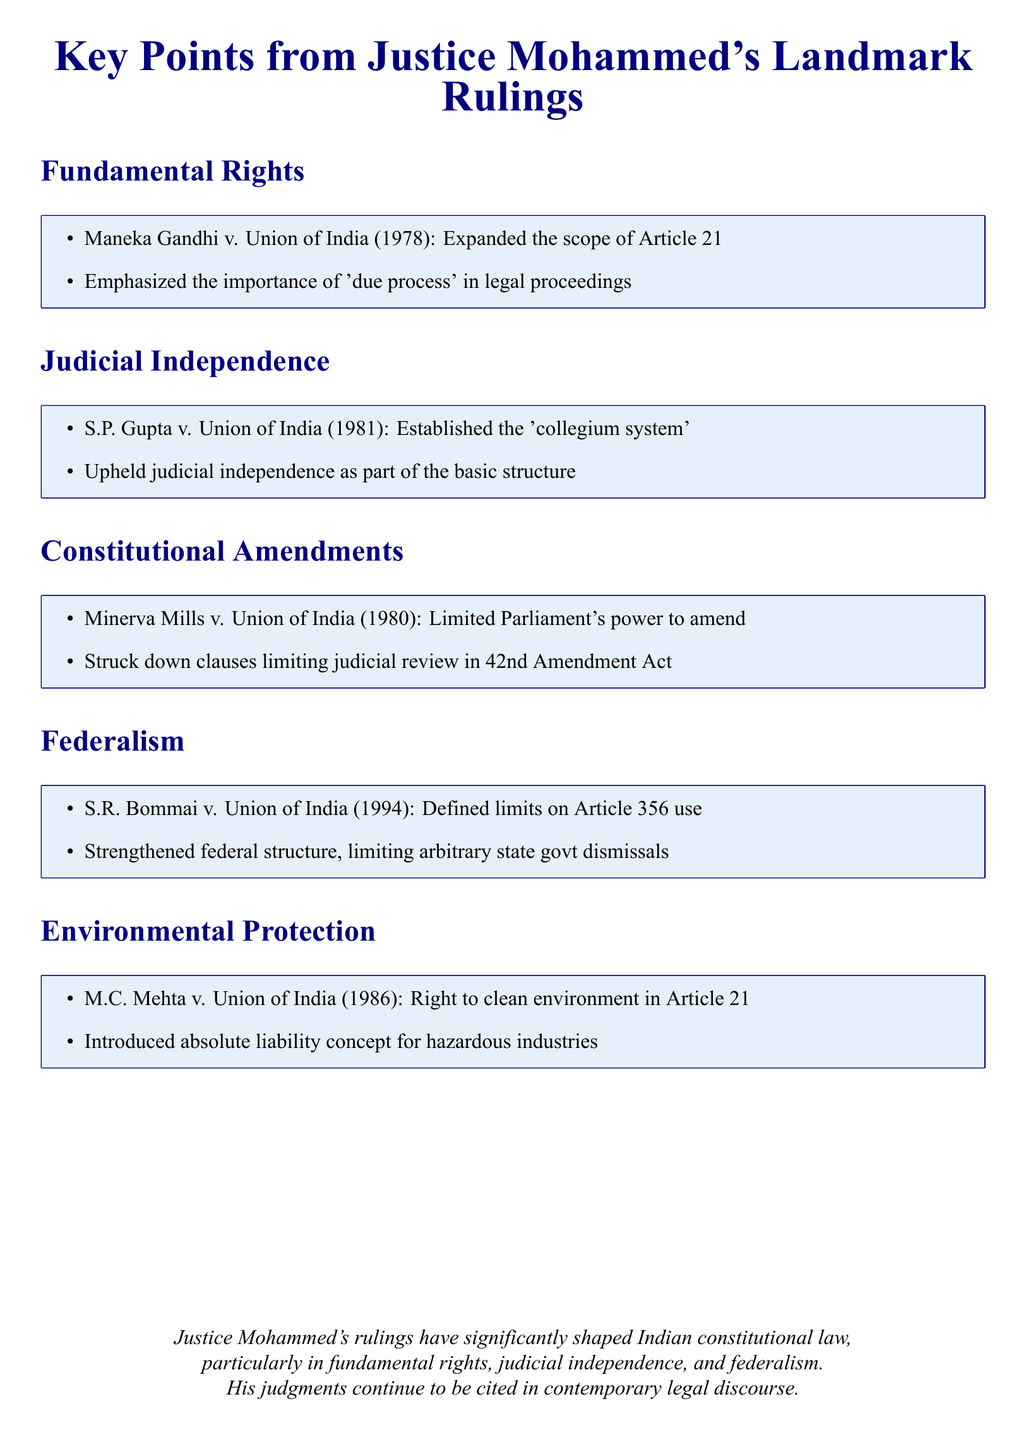What case expanded the scope of Article 21? The case is Maneka Gandhi v. Union of India (1978), which is mentioned in the Fundamental Rights section.
Answer: Maneka Gandhi v. Union of India (1978) What constitutional principle was upheld in S.P. Gupta v. Union of India? It upheld the principle of judicial independence, which is highlighted in the Judicial Independence section.
Answer: Judicial independence Which case limited Parliament's power to amend the Constitution? This is addressed in the Constitutional Amendments section, specifically in the Minerva Mills v. Union of India (1980) case.
Answer: Minerva Mills v. Union of India (1980) What concept did M.C. Mehta v. Union of India introduce for hazardous industries? The case introduced the concept of absolute liability, as noted in the Environmental Protection section.
Answer: Absolute liability In which year did the S.R. Bommai case define limits on Article 356? The case was decided in 1994, which is specified in the Federalism section.
Answer: 1994 What is a key component of Justice Mohammed's rulings in Indian constitutional law? The key component mentioned is fundamental rights, judicial independence, and federalism, as summarized in the conclusion.
Answer: Fundamental rights, judicial independence, and federalism What was struck down in the 42nd Amendment Act according to Minerva Mills v. Union of India? Clauses that sought to limit judicial review were struck down, as mentioned in the Constitutional Amendments section.
Answer: Clauses limiting judicial review What key legal concept did Justice Mohammed emphasize in legal proceedings? He emphasized the importance of 'due process,' as mentioned in the Fundamental Rights section.
Answer: Due process What ruling is associated with environmental rights in 1986? The ruling associated with environmental rights in 1986 is M.C. Mehta v. Union of India, referenced in the Environmental Protection section.
Answer: M.C. Mehta v. Union of India (1986) 